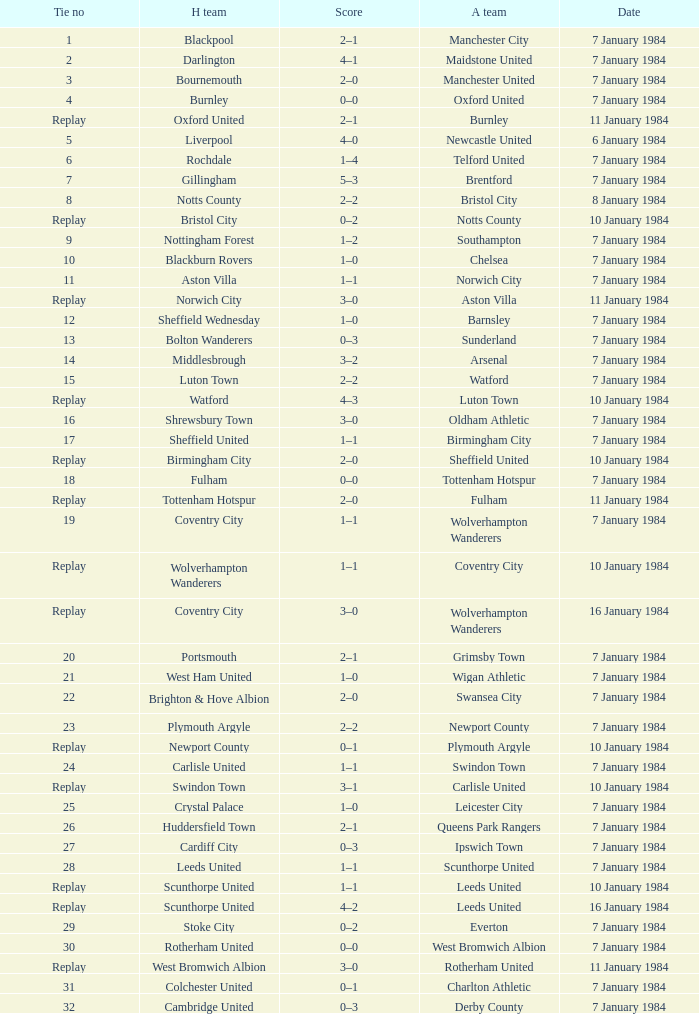Who was the away team with a tie of 14? Arsenal. 